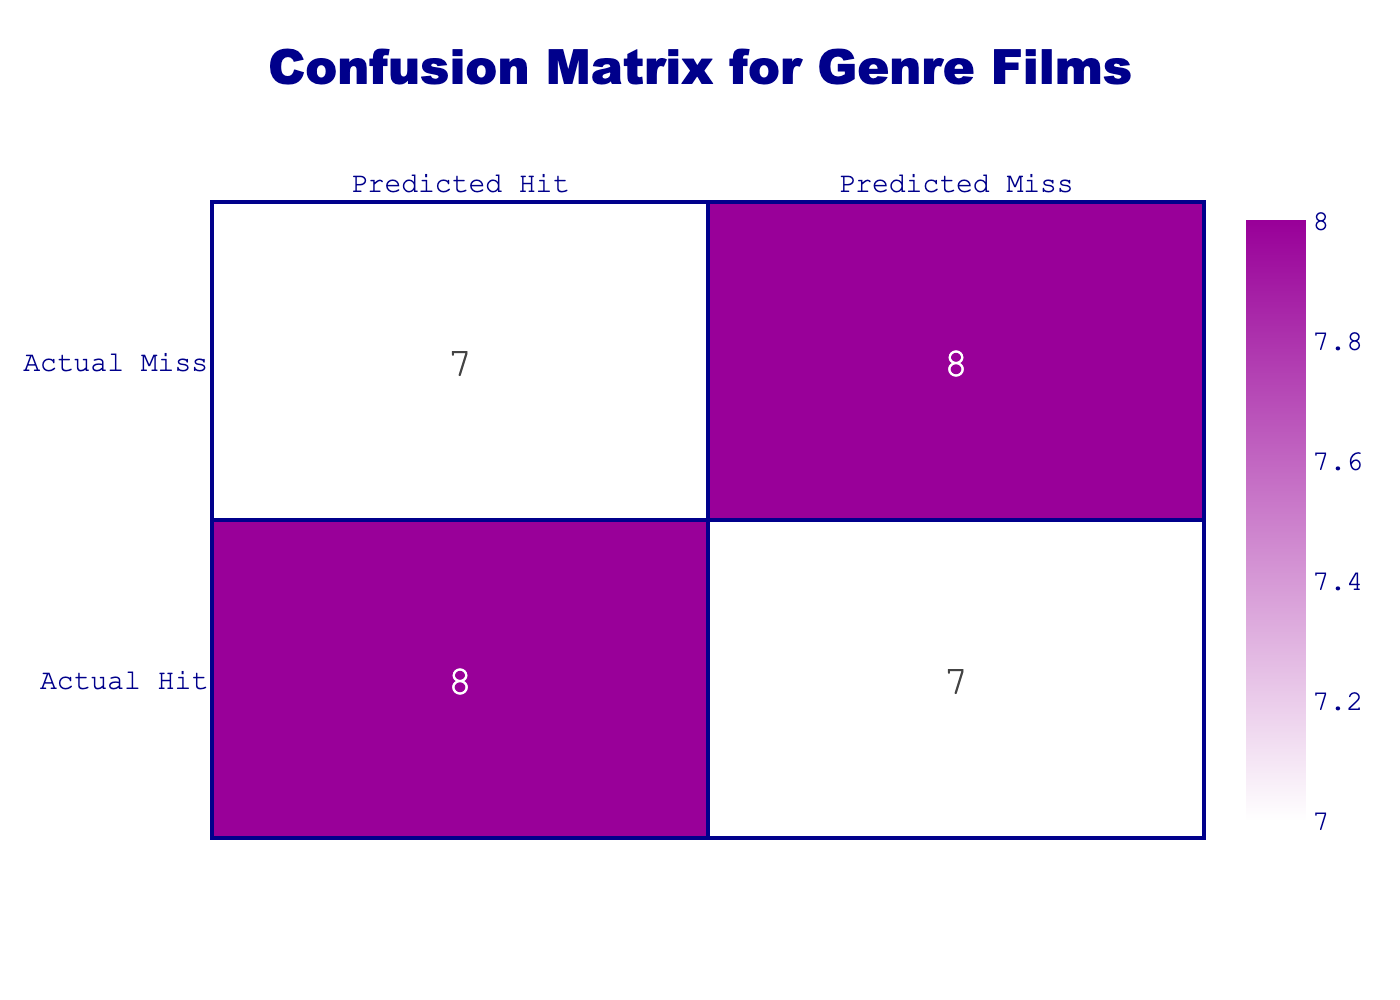What is the number of films that were predicted as Hits? The predicted Hits correspond to the outcomes where the actual ratings were also Hits. According to the table, there are 5 instances where the Outcome is "Hit."
Answer: 5 What is the number of films that were predicted as Misses? The predicted Misses correspond to the outcomes where the actual ratings were also Misses. By counting the occurrences of the outcome "Miss," there are also 5 films in this category.
Answer: 5 How many films were actual Hits? There are 5 films labeled as "Hit" in the Outcome column. This is directly observable from the table.
Answer: 5 How many films were actual Misses? The number of films labeled as "Miss" can be determined by counting the total occurrences of that label in the table, which amounts to 5 films.
Answer: 5 What is the ratio of Hits to Misses? The ratio can be calculated by taking the number of Hits (5) and dividing it by the number of Misses (5). This yields a ratio of 1:1.
Answer: 1:1 Did any film with a viewer rating of 8 or higher end up being a Miss? Yes, "The Walking Dead (Season 10)" has a viewer rating of 7.8 and is categorized as a Miss. Thus, at least one film with a viewer rating of 8 or higher resulted in a Miss.
Answer: Yes Is it true that all films with a viewer rating below 6 were Hits? No, both "Piranha II: The Spawning" with a viewer rating of 4.1 and "Howard the Duck" with a viewer rating of 4.2 are categorized as Misses.
Answer: No What film had the highest critic score among those that were Hits? "Aliens" has the highest critic score of 97, while being classified as a Hit. This is easily identifiable from the "Critic Score" column.
Answer: Aliens What is the average viewer rating for films categorized as Hits? The viewer ratings for the Hits are 8.5, 8.0, 8.4, 8.2, and 8.7. Summing them up gives 41.8. Dividing by the number of Hits (5) provides an average of 41.8 / 5 = 8.36.
Answer: 8.36 Which film with the lowest viewer rating was categorized as a Hit? "Dusk Till Dawn" has a viewer rating of 7.6 and is considered a Hit; checking through all entries shows that it is indeed the lowest among the Hits.
Answer: Dusk Till Dawn 